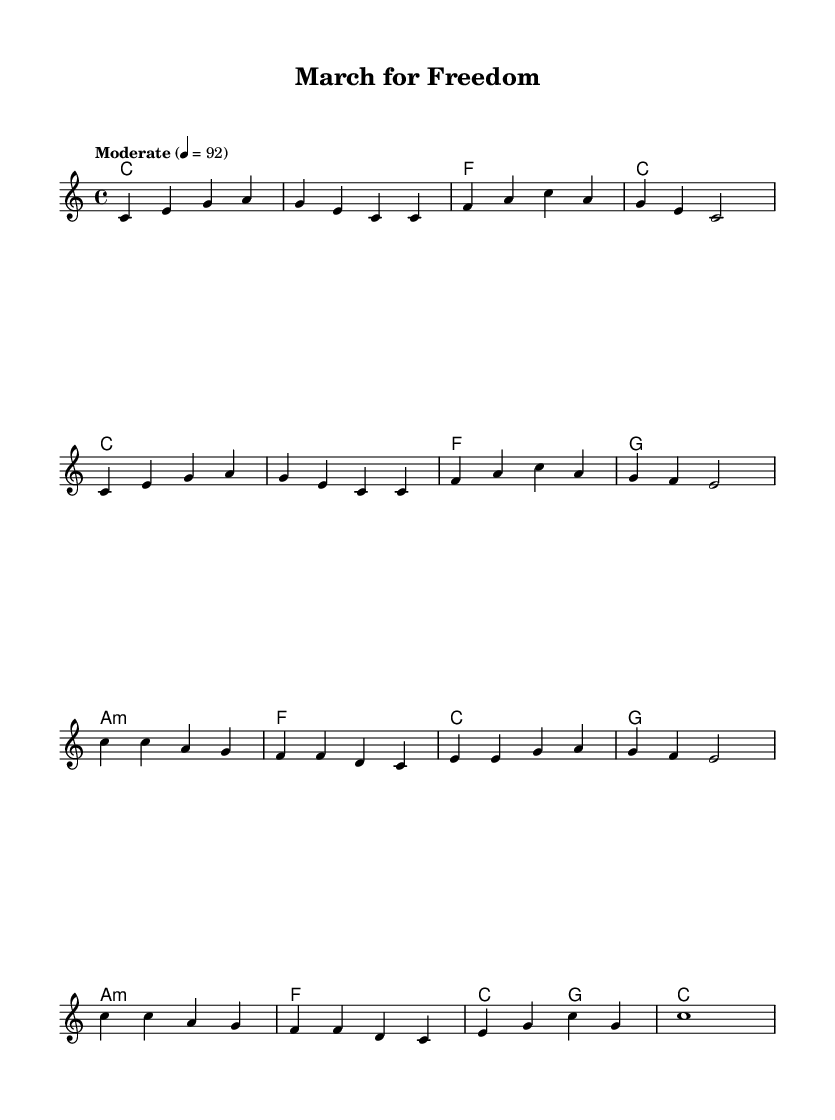What is the time signature of this music? The time signature is indicated by the notation "4/4", which means there are four beats in each measure and the quarter note receives one beat.
Answer: 4/4 What is the tempo marking for this piece? The tempo marking "Moderate" with a metronome marking of "4 = 92" indicates that there should be a moderate pace, with 92 quarter note beats per minute.
Answer: Moderate 4 = 92 How many measures are in the melody section? By counting the distinct groups of notes divided by vertical lines, there are a total of 12 measures in the melody section.
Answer: 12 What is the last chord in the piece? The last chord is indicated in the harmonic section as "c1," which refers to a C major chord held for a whole note.
Answer: c Are there any minor chords in the harmonies? The chord labeled "a:m" indicates an A minor chord, which is a type of minor chord noted within the harmonies section.
Answer: Yes What is the highest note in the melody? Reviewing the melody, the highest note is "c'", which is an octave above middle C, indicated by the apostrophe.
Answer: c' 